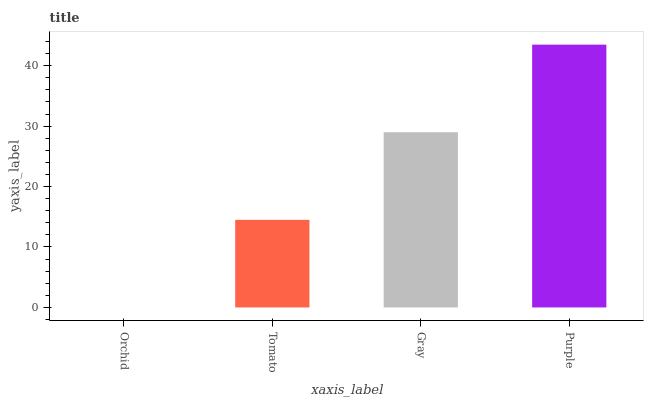Is Orchid the minimum?
Answer yes or no. Yes. Is Purple the maximum?
Answer yes or no. Yes. Is Tomato the minimum?
Answer yes or no. No. Is Tomato the maximum?
Answer yes or no. No. Is Tomato greater than Orchid?
Answer yes or no. Yes. Is Orchid less than Tomato?
Answer yes or no. Yes. Is Orchid greater than Tomato?
Answer yes or no. No. Is Tomato less than Orchid?
Answer yes or no. No. Is Gray the high median?
Answer yes or no. Yes. Is Tomato the low median?
Answer yes or no. Yes. Is Tomato the high median?
Answer yes or no. No. Is Purple the low median?
Answer yes or no. No. 